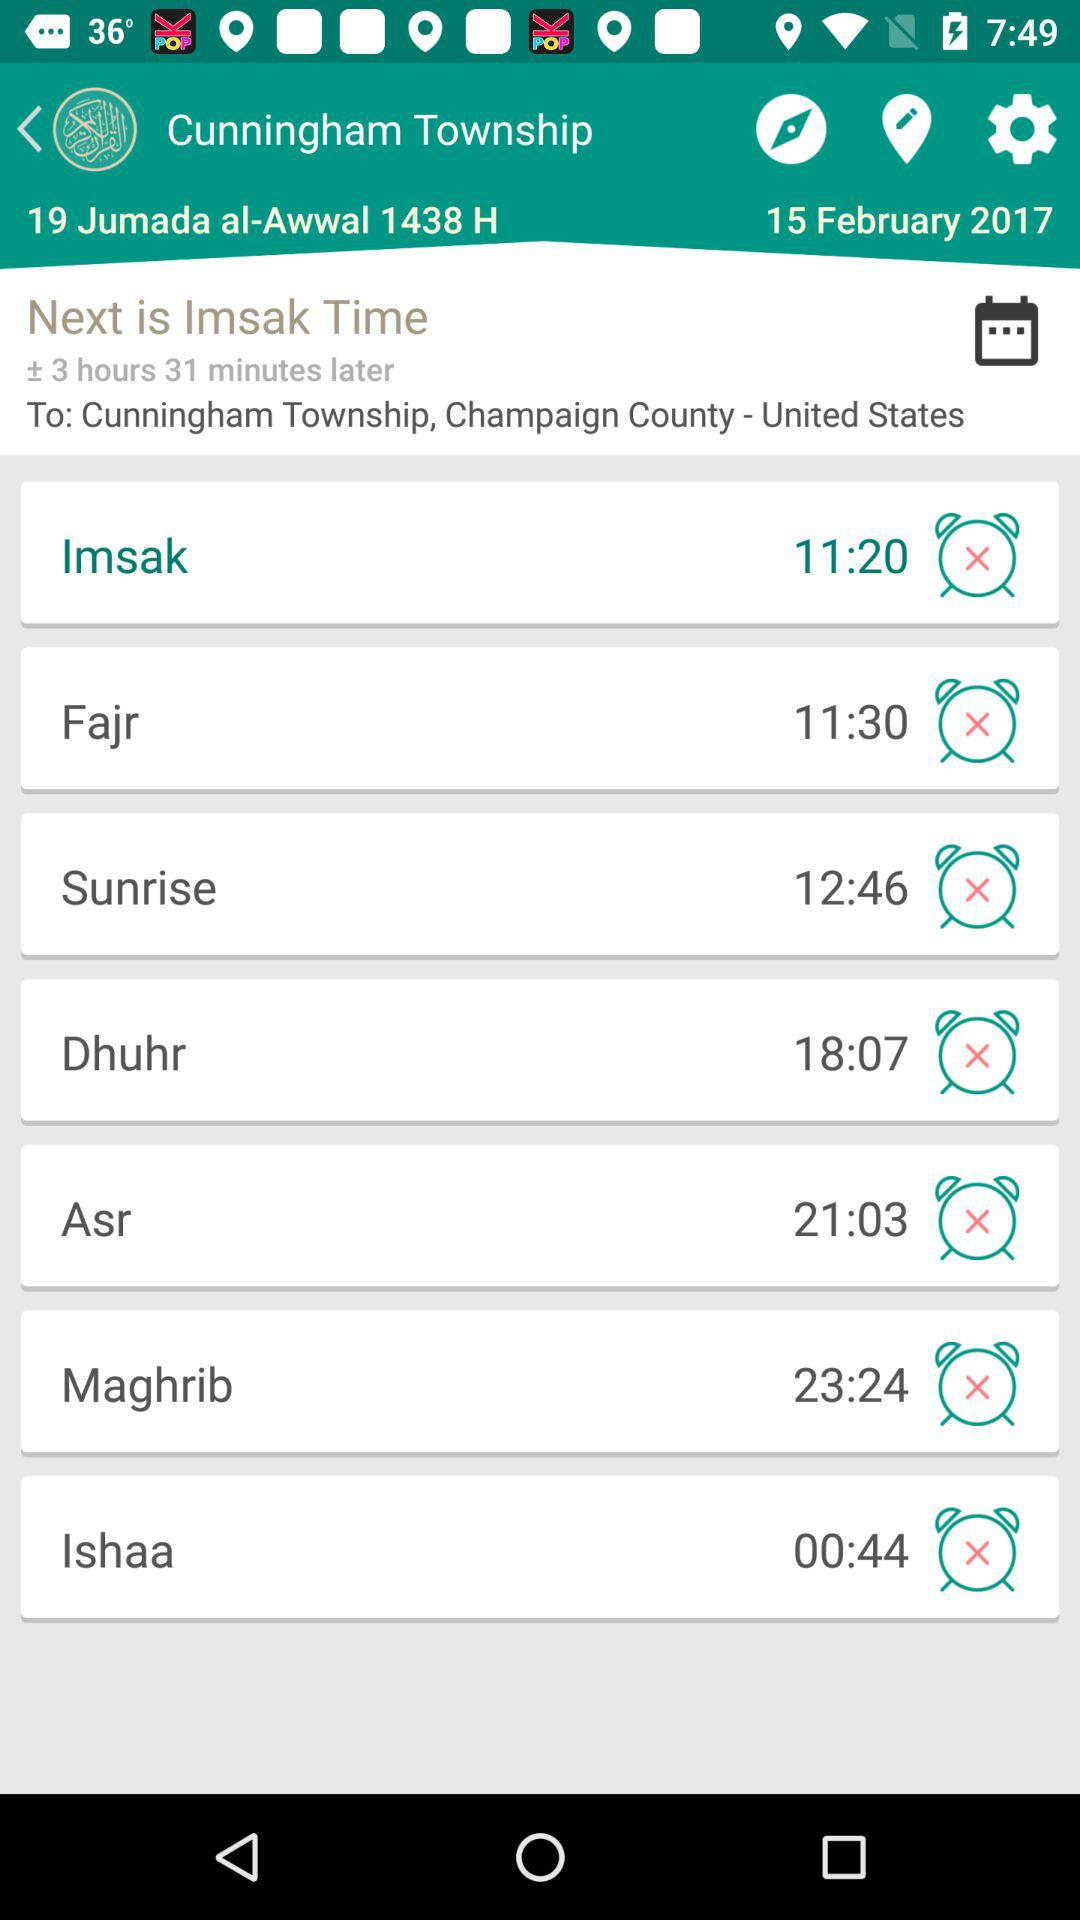What is the location for "Imsak time"? The location for "Imsak time" is Cunningham Township, Champaign County - United States. 